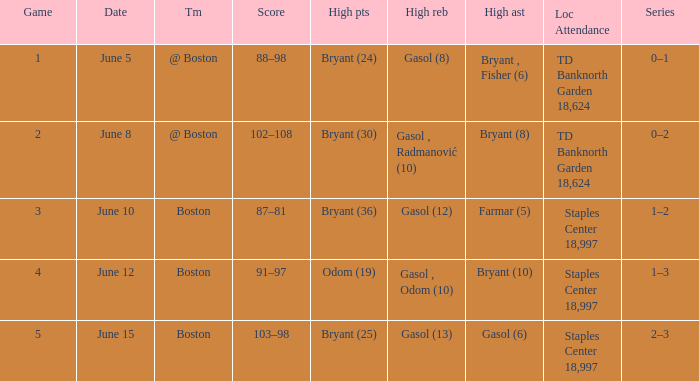Name the location on june 10 Staples Center 18,997. 